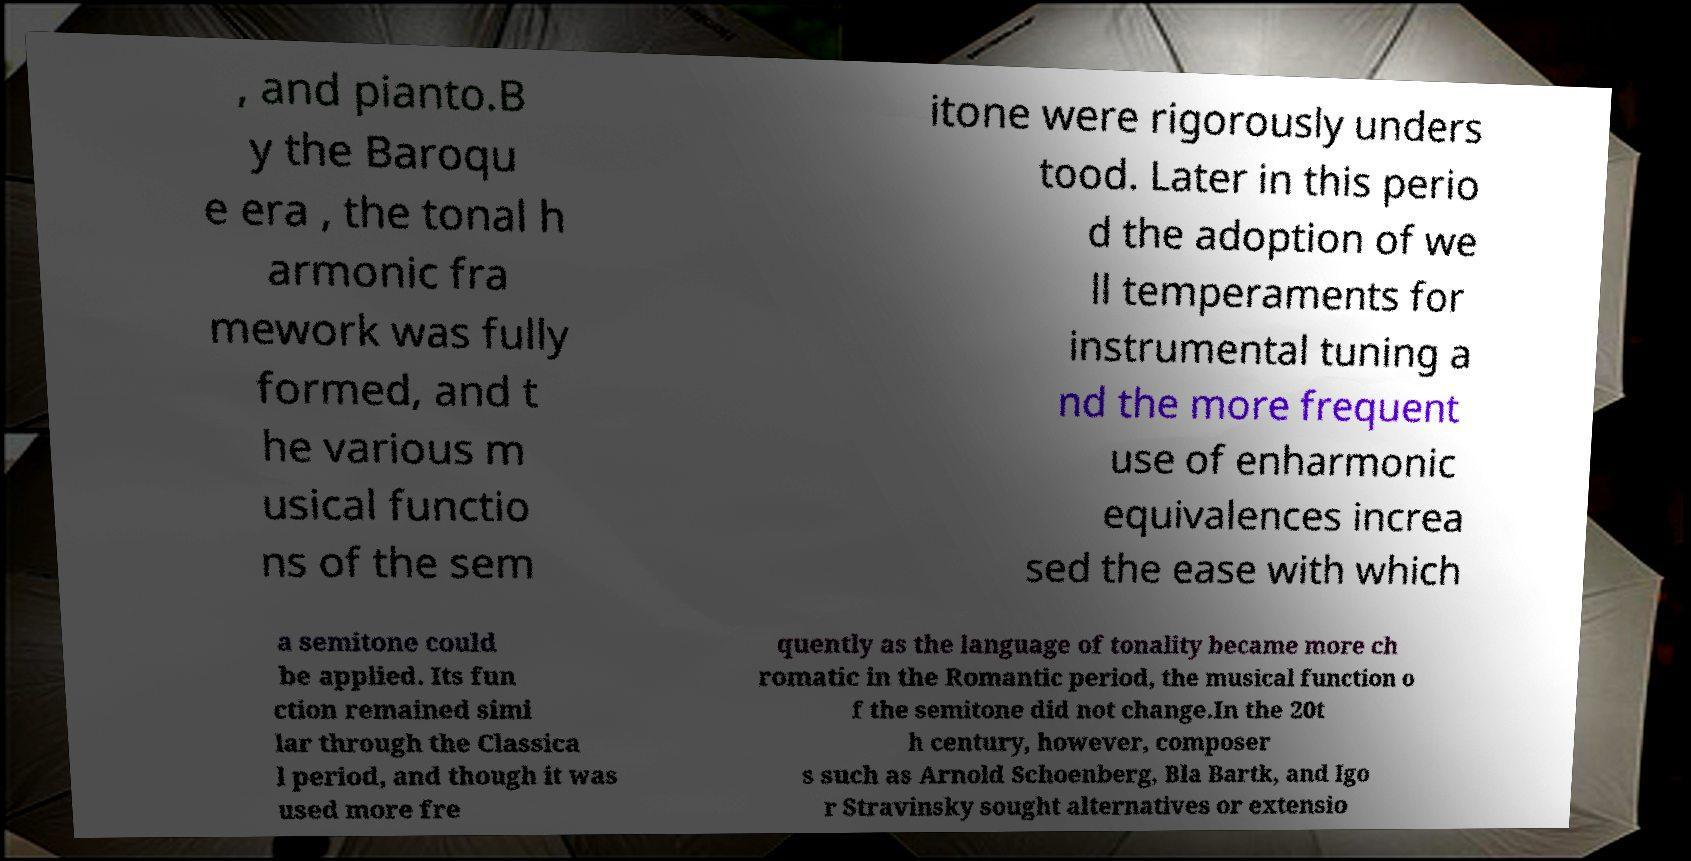Please identify and transcribe the text found in this image. , and pianto.B y the Baroqu e era , the tonal h armonic fra mework was fully formed, and t he various m usical functio ns of the sem itone were rigorously unders tood. Later in this perio d the adoption of we ll temperaments for instrumental tuning a nd the more frequent use of enharmonic equivalences increa sed the ease with which a semitone could be applied. Its fun ction remained simi lar through the Classica l period, and though it was used more fre quently as the language of tonality became more ch romatic in the Romantic period, the musical function o f the semitone did not change.In the 20t h century, however, composer s such as Arnold Schoenberg, Bla Bartk, and Igo r Stravinsky sought alternatives or extensio 